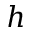Convert formula to latex. <formula><loc_0><loc_0><loc_500><loc_500>h</formula> 